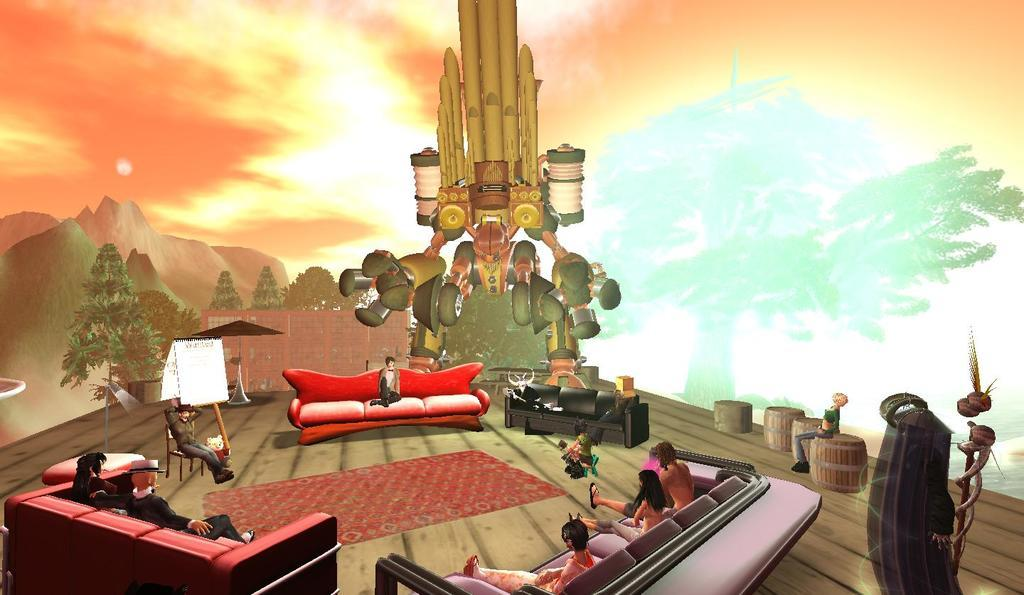What types of images are present in the image? There are different animations in the image. Can you describe the setting of the animations? There are depictions of people sitting on sofas. What additional features are present in the image? There are visual effects around the people sitting on sofas. How many ants can be seen crawling on the record in the image? There is no record or ants present in the image. 